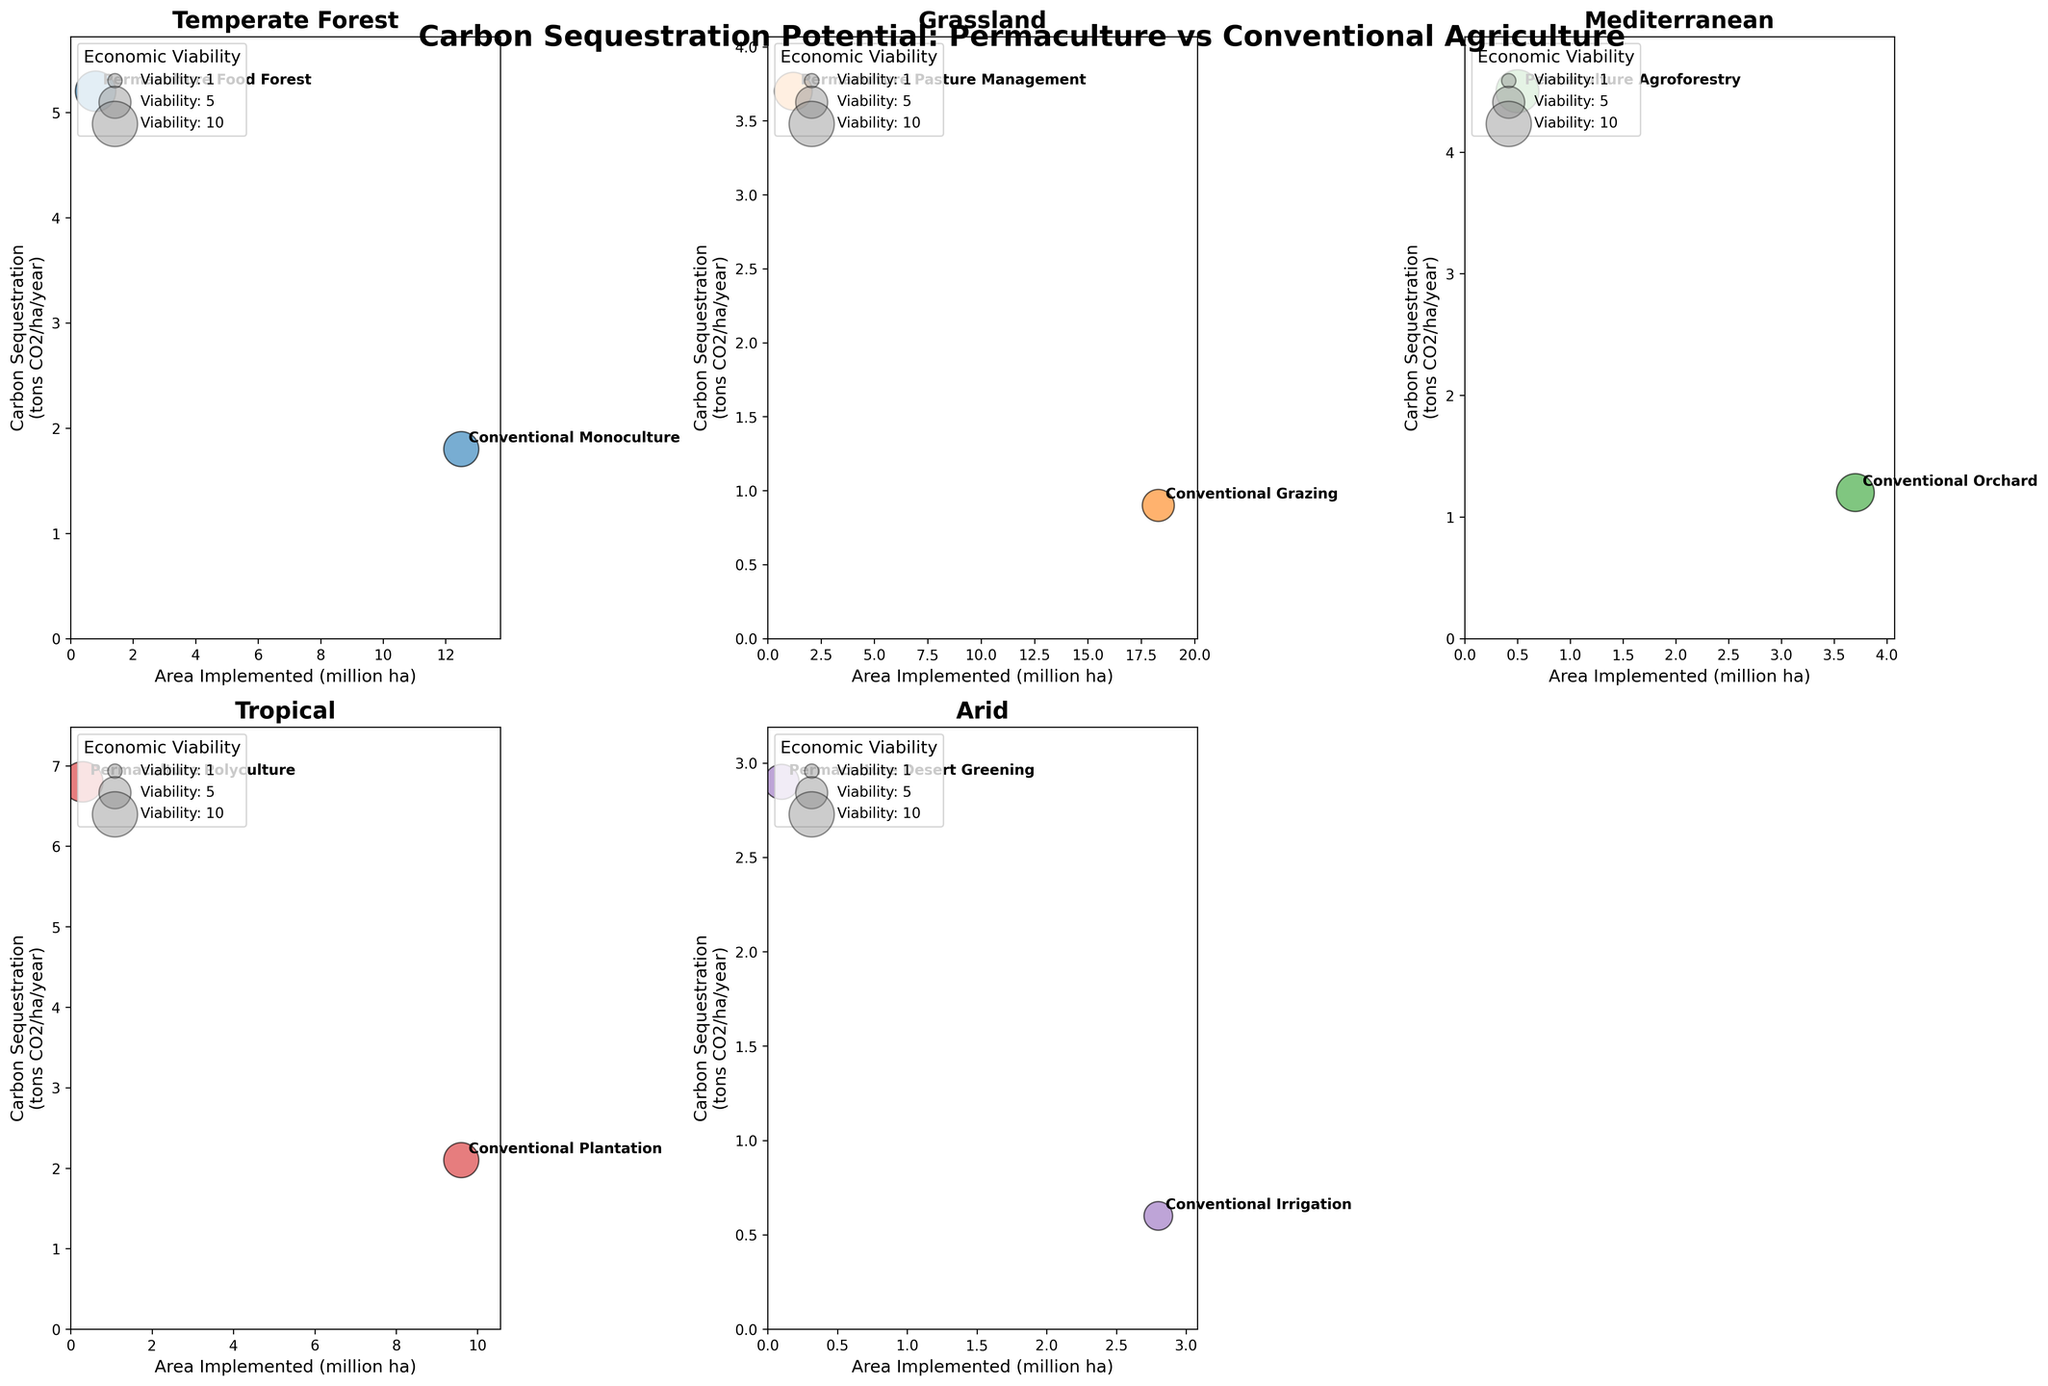What's the title of the figure? The title is usually placed at the top of the plot, encompassing the entire figure. In this case, the title is "Carbon Sequestration Potential: Permaculture vs Conventional Agriculture".
Answer: Carbon Sequestration Potential: Permaculture vs Conventional Agriculture How many subplots are included in the figure? By observing the layout of the figure, we can count the number of individual graphs. There are 5 populated subplots and 1 extra subplot that is removed (total 6 areas, but 1 is empty).
Answer: 5 Which ecosystem type has the highest Carbon Sequestration potential under permaculture practices? We need to identify which subplot shows the highest Carbon Sequestration value (y-axis) for a permaculture practice. The "Tropical" ecosystem with "Permaculture Polyculture" has the highest value at 6.8 tons CO2/ha/year.
Answer: Tropical What is the Economic Viability of Permaculture Desert Greening practices? We can find the bubble representing "Permaculture Desert Greening" in the "Arid" subplot and check its size and the legend. It shows a value of 6.
Answer: 6 How does Carbon Sequestration under Permaculture Pasture Management compare to Conventional Grazing in grasslands? We compare the y-axis values for "Permaculture Pasture Management" and "Conventional Grazing" in the "Grassland" subplot. Permaculture Pasture Management has 3.7 tons CO2/ha/year, while Conventional Grazing has 0.9 tons CO2/ha/year.
Answer: Permaculture Pasture Management is higher Which ecosystem has the largest area implemented under conventional practice? By checking the x-axis values for conventional practices across all subplots, the "Grassland" ecosystem with "Conventional Grazing" has the highest area implemented at 18.3 million ha.
Answer: Grassland What is the difference in Carbon Sequestration between Permaculture Polyculture and Conventional Plantation in the Tropical ecosystem? Subtract the Carbon Sequestration value of "Conventional Plantation" from "Permaculture Polyculture" in the "Tropical" subplot: 6.8 - 2.1 = 4.7 tons CO2/ha/year.
Answer: 4.7 tons CO2/ha/year Which practice has the lowest Carbon Sequestration potential in the figure? By examining the y-axis values across all subplots, "Conventional Irrigation" in the "Arid" ecosystem has the lowest value at 0.6 tons CO2/ha/year.
Answer: Conventional Irrigation 